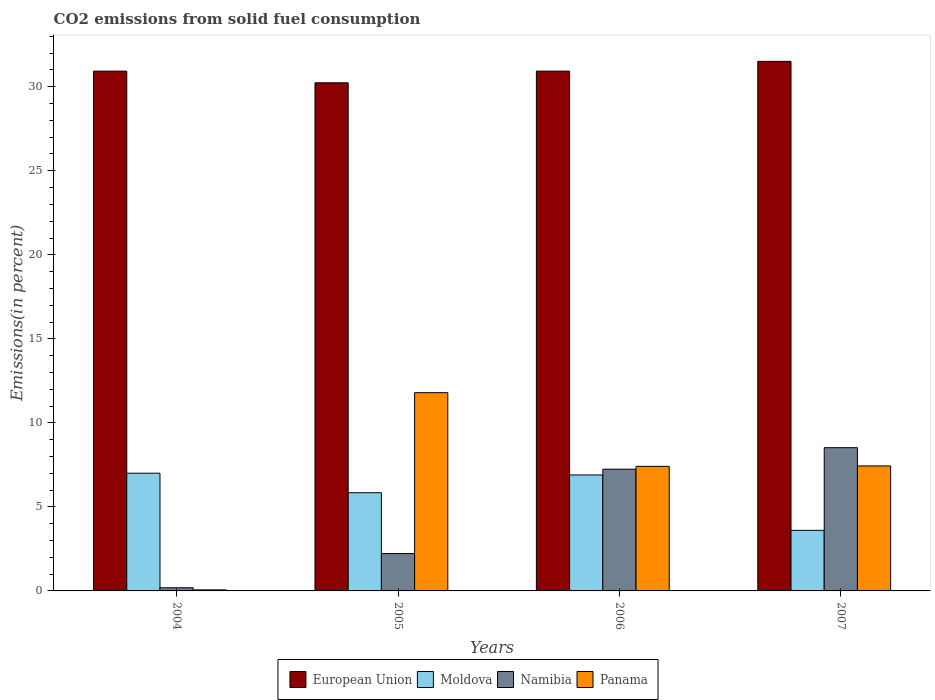How many different coloured bars are there?
Your answer should be compact. 4. How many bars are there on the 3rd tick from the left?
Give a very brief answer. 4. How many bars are there on the 2nd tick from the right?
Provide a succinct answer. 4. What is the label of the 1st group of bars from the left?
Your answer should be compact. 2004. What is the total CO2 emitted in Moldova in 2005?
Make the answer very short. 5.84. Across all years, what is the maximum total CO2 emitted in Panama?
Provide a short and direct response. 11.8. Across all years, what is the minimum total CO2 emitted in Namibia?
Your answer should be very brief. 0.19. In which year was the total CO2 emitted in Namibia maximum?
Your response must be concise. 2007. In which year was the total CO2 emitted in Namibia minimum?
Give a very brief answer. 2004. What is the total total CO2 emitted in European Union in the graph?
Ensure brevity in your answer.  123.61. What is the difference between the total CO2 emitted in Panama in 2005 and that in 2006?
Your answer should be compact. 4.38. What is the difference between the total CO2 emitted in Namibia in 2007 and the total CO2 emitted in European Union in 2004?
Ensure brevity in your answer.  -22.41. What is the average total CO2 emitted in Moldova per year?
Offer a very short reply. 5.84. In the year 2004, what is the difference between the total CO2 emitted in Panama and total CO2 emitted in Moldova?
Keep it short and to the point. -6.94. What is the ratio of the total CO2 emitted in Moldova in 2005 to that in 2007?
Provide a succinct answer. 1.62. Is the total CO2 emitted in Panama in 2005 less than that in 2006?
Your answer should be very brief. No. Is the difference between the total CO2 emitted in Panama in 2004 and 2005 greater than the difference between the total CO2 emitted in Moldova in 2004 and 2005?
Ensure brevity in your answer.  No. What is the difference between the highest and the second highest total CO2 emitted in Panama?
Make the answer very short. 4.36. What is the difference between the highest and the lowest total CO2 emitted in European Union?
Provide a succinct answer. 1.28. What does the 3rd bar from the left in 2007 represents?
Make the answer very short. Namibia. What does the 1st bar from the right in 2005 represents?
Provide a short and direct response. Panama. Is it the case that in every year, the sum of the total CO2 emitted in Namibia and total CO2 emitted in Moldova is greater than the total CO2 emitted in European Union?
Provide a succinct answer. No. Are all the bars in the graph horizontal?
Keep it short and to the point. No. Does the graph contain grids?
Your answer should be very brief. No. Where does the legend appear in the graph?
Provide a short and direct response. Bottom center. What is the title of the graph?
Give a very brief answer. CO2 emissions from solid fuel consumption. What is the label or title of the Y-axis?
Offer a very short reply. Emissions(in percent). What is the Emissions(in percent) of European Union in 2004?
Offer a very short reply. 30.93. What is the Emissions(in percent) in Moldova in 2004?
Provide a short and direct response. 7. What is the Emissions(in percent) of Namibia in 2004?
Offer a very short reply. 0.19. What is the Emissions(in percent) of Panama in 2004?
Ensure brevity in your answer.  0.06. What is the Emissions(in percent) of European Union in 2005?
Keep it short and to the point. 30.24. What is the Emissions(in percent) in Moldova in 2005?
Your answer should be compact. 5.84. What is the Emissions(in percent) in Namibia in 2005?
Ensure brevity in your answer.  2.22. What is the Emissions(in percent) of Panama in 2005?
Ensure brevity in your answer.  11.8. What is the Emissions(in percent) of European Union in 2006?
Give a very brief answer. 30.93. What is the Emissions(in percent) of Moldova in 2006?
Your answer should be compact. 6.9. What is the Emissions(in percent) of Namibia in 2006?
Give a very brief answer. 7.24. What is the Emissions(in percent) of Panama in 2006?
Ensure brevity in your answer.  7.41. What is the Emissions(in percent) in European Union in 2007?
Make the answer very short. 31.51. What is the Emissions(in percent) in Moldova in 2007?
Keep it short and to the point. 3.61. What is the Emissions(in percent) of Namibia in 2007?
Offer a very short reply. 8.52. What is the Emissions(in percent) in Panama in 2007?
Provide a succinct answer. 7.44. Across all years, what is the maximum Emissions(in percent) in European Union?
Your response must be concise. 31.51. Across all years, what is the maximum Emissions(in percent) of Moldova?
Give a very brief answer. 7. Across all years, what is the maximum Emissions(in percent) in Namibia?
Provide a succinct answer. 8.52. Across all years, what is the maximum Emissions(in percent) in Panama?
Provide a short and direct response. 11.8. Across all years, what is the minimum Emissions(in percent) of European Union?
Keep it short and to the point. 30.24. Across all years, what is the minimum Emissions(in percent) in Moldova?
Ensure brevity in your answer.  3.61. Across all years, what is the minimum Emissions(in percent) in Namibia?
Offer a very short reply. 0.19. Across all years, what is the minimum Emissions(in percent) of Panama?
Your answer should be very brief. 0.06. What is the total Emissions(in percent) of European Union in the graph?
Provide a succinct answer. 123.61. What is the total Emissions(in percent) in Moldova in the graph?
Keep it short and to the point. 23.35. What is the total Emissions(in percent) of Namibia in the graph?
Make the answer very short. 18.18. What is the total Emissions(in percent) of Panama in the graph?
Provide a succinct answer. 26.71. What is the difference between the Emissions(in percent) in European Union in 2004 and that in 2005?
Ensure brevity in your answer.  0.69. What is the difference between the Emissions(in percent) in Moldova in 2004 and that in 2005?
Offer a terse response. 1.16. What is the difference between the Emissions(in percent) in Namibia in 2004 and that in 2005?
Your answer should be compact. -2.04. What is the difference between the Emissions(in percent) of Panama in 2004 and that in 2005?
Offer a very short reply. -11.73. What is the difference between the Emissions(in percent) of European Union in 2004 and that in 2006?
Your answer should be compact. 0. What is the difference between the Emissions(in percent) of Moldova in 2004 and that in 2006?
Your answer should be very brief. 0.1. What is the difference between the Emissions(in percent) of Namibia in 2004 and that in 2006?
Give a very brief answer. -7.06. What is the difference between the Emissions(in percent) of Panama in 2004 and that in 2006?
Offer a very short reply. -7.35. What is the difference between the Emissions(in percent) of European Union in 2004 and that in 2007?
Your answer should be compact. -0.58. What is the difference between the Emissions(in percent) of Moldova in 2004 and that in 2007?
Your answer should be compact. 3.4. What is the difference between the Emissions(in percent) in Namibia in 2004 and that in 2007?
Make the answer very short. -8.34. What is the difference between the Emissions(in percent) in Panama in 2004 and that in 2007?
Make the answer very short. -7.37. What is the difference between the Emissions(in percent) of European Union in 2005 and that in 2006?
Your response must be concise. -0.69. What is the difference between the Emissions(in percent) in Moldova in 2005 and that in 2006?
Your response must be concise. -1.06. What is the difference between the Emissions(in percent) of Namibia in 2005 and that in 2006?
Provide a succinct answer. -5.02. What is the difference between the Emissions(in percent) of Panama in 2005 and that in 2006?
Your answer should be compact. 4.38. What is the difference between the Emissions(in percent) in European Union in 2005 and that in 2007?
Make the answer very short. -1.28. What is the difference between the Emissions(in percent) in Moldova in 2005 and that in 2007?
Provide a short and direct response. 2.24. What is the difference between the Emissions(in percent) in Namibia in 2005 and that in 2007?
Offer a terse response. -6.3. What is the difference between the Emissions(in percent) of Panama in 2005 and that in 2007?
Offer a very short reply. 4.36. What is the difference between the Emissions(in percent) of European Union in 2006 and that in 2007?
Offer a terse response. -0.58. What is the difference between the Emissions(in percent) in Moldova in 2006 and that in 2007?
Give a very brief answer. 3.3. What is the difference between the Emissions(in percent) in Namibia in 2006 and that in 2007?
Make the answer very short. -1.28. What is the difference between the Emissions(in percent) of Panama in 2006 and that in 2007?
Make the answer very short. -0.02. What is the difference between the Emissions(in percent) in European Union in 2004 and the Emissions(in percent) in Moldova in 2005?
Make the answer very short. 25.09. What is the difference between the Emissions(in percent) in European Union in 2004 and the Emissions(in percent) in Namibia in 2005?
Offer a terse response. 28.71. What is the difference between the Emissions(in percent) of European Union in 2004 and the Emissions(in percent) of Panama in 2005?
Your answer should be very brief. 19.13. What is the difference between the Emissions(in percent) of Moldova in 2004 and the Emissions(in percent) of Namibia in 2005?
Offer a terse response. 4.78. What is the difference between the Emissions(in percent) of Moldova in 2004 and the Emissions(in percent) of Panama in 2005?
Provide a short and direct response. -4.79. What is the difference between the Emissions(in percent) of Namibia in 2004 and the Emissions(in percent) of Panama in 2005?
Your answer should be compact. -11.61. What is the difference between the Emissions(in percent) of European Union in 2004 and the Emissions(in percent) of Moldova in 2006?
Ensure brevity in your answer.  24.03. What is the difference between the Emissions(in percent) in European Union in 2004 and the Emissions(in percent) in Namibia in 2006?
Make the answer very short. 23.69. What is the difference between the Emissions(in percent) in European Union in 2004 and the Emissions(in percent) in Panama in 2006?
Keep it short and to the point. 23.52. What is the difference between the Emissions(in percent) of Moldova in 2004 and the Emissions(in percent) of Namibia in 2006?
Offer a very short reply. -0.24. What is the difference between the Emissions(in percent) in Moldova in 2004 and the Emissions(in percent) in Panama in 2006?
Ensure brevity in your answer.  -0.41. What is the difference between the Emissions(in percent) of Namibia in 2004 and the Emissions(in percent) of Panama in 2006?
Your answer should be very brief. -7.23. What is the difference between the Emissions(in percent) of European Union in 2004 and the Emissions(in percent) of Moldova in 2007?
Provide a succinct answer. 27.33. What is the difference between the Emissions(in percent) in European Union in 2004 and the Emissions(in percent) in Namibia in 2007?
Keep it short and to the point. 22.41. What is the difference between the Emissions(in percent) in European Union in 2004 and the Emissions(in percent) in Panama in 2007?
Your answer should be compact. 23.49. What is the difference between the Emissions(in percent) of Moldova in 2004 and the Emissions(in percent) of Namibia in 2007?
Give a very brief answer. -1.52. What is the difference between the Emissions(in percent) of Moldova in 2004 and the Emissions(in percent) of Panama in 2007?
Keep it short and to the point. -0.43. What is the difference between the Emissions(in percent) of Namibia in 2004 and the Emissions(in percent) of Panama in 2007?
Your answer should be compact. -7.25. What is the difference between the Emissions(in percent) of European Union in 2005 and the Emissions(in percent) of Moldova in 2006?
Ensure brevity in your answer.  23.34. What is the difference between the Emissions(in percent) in European Union in 2005 and the Emissions(in percent) in Namibia in 2006?
Make the answer very short. 22.99. What is the difference between the Emissions(in percent) of European Union in 2005 and the Emissions(in percent) of Panama in 2006?
Offer a terse response. 22.82. What is the difference between the Emissions(in percent) of Moldova in 2005 and the Emissions(in percent) of Namibia in 2006?
Provide a short and direct response. -1.4. What is the difference between the Emissions(in percent) in Moldova in 2005 and the Emissions(in percent) in Panama in 2006?
Make the answer very short. -1.57. What is the difference between the Emissions(in percent) of Namibia in 2005 and the Emissions(in percent) of Panama in 2006?
Your answer should be compact. -5.19. What is the difference between the Emissions(in percent) in European Union in 2005 and the Emissions(in percent) in Moldova in 2007?
Your answer should be compact. 26.63. What is the difference between the Emissions(in percent) of European Union in 2005 and the Emissions(in percent) of Namibia in 2007?
Your response must be concise. 21.71. What is the difference between the Emissions(in percent) in European Union in 2005 and the Emissions(in percent) in Panama in 2007?
Provide a succinct answer. 22.8. What is the difference between the Emissions(in percent) in Moldova in 2005 and the Emissions(in percent) in Namibia in 2007?
Give a very brief answer. -2.68. What is the difference between the Emissions(in percent) of Moldova in 2005 and the Emissions(in percent) of Panama in 2007?
Keep it short and to the point. -1.59. What is the difference between the Emissions(in percent) of Namibia in 2005 and the Emissions(in percent) of Panama in 2007?
Offer a very short reply. -5.22. What is the difference between the Emissions(in percent) of European Union in 2006 and the Emissions(in percent) of Moldova in 2007?
Make the answer very short. 27.33. What is the difference between the Emissions(in percent) of European Union in 2006 and the Emissions(in percent) of Namibia in 2007?
Your answer should be very brief. 22.41. What is the difference between the Emissions(in percent) of European Union in 2006 and the Emissions(in percent) of Panama in 2007?
Your response must be concise. 23.49. What is the difference between the Emissions(in percent) of Moldova in 2006 and the Emissions(in percent) of Namibia in 2007?
Your answer should be very brief. -1.62. What is the difference between the Emissions(in percent) in Moldova in 2006 and the Emissions(in percent) in Panama in 2007?
Offer a terse response. -0.54. What is the difference between the Emissions(in percent) in Namibia in 2006 and the Emissions(in percent) in Panama in 2007?
Offer a terse response. -0.19. What is the average Emissions(in percent) of European Union per year?
Your response must be concise. 30.9. What is the average Emissions(in percent) in Moldova per year?
Ensure brevity in your answer.  5.84. What is the average Emissions(in percent) of Namibia per year?
Provide a succinct answer. 4.54. What is the average Emissions(in percent) of Panama per year?
Make the answer very short. 6.68. In the year 2004, what is the difference between the Emissions(in percent) of European Union and Emissions(in percent) of Moldova?
Your response must be concise. 23.93. In the year 2004, what is the difference between the Emissions(in percent) of European Union and Emissions(in percent) of Namibia?
Provide a short and direct response. 30.74. In the year 2004, what is the difference between the Emissions(in percent) in European Union and Emissions(in percent) in Panama?
Keep it short and to the point. 30.87. In the year 2004, what is the difference between the Emissions(in percent) of Moldova and Emissions(in percent) of Namibia?
Provide a succinct answer. 6.82. In the year 2004, what is the difference between the Emissions(in percent) in Moldova and Emissions(in percent) in Panama?
Make the answer very short. 6.94. In the year 2004, what is the difference between the Emissions(in percent) in Namibia and Emissions(in percent) in Panama?
Offer a terse response. 0.12. In the year 2005, what is the difference between the Emissions(in percent) in European Union and Emissions(in percent) in Moldova?
Give a very brief answer. 24.39. In the year 2005, what is the difference between the Emissions(in percent) of European Union and Emissions(in percent) of Namibia?
Your answer should be compact. 28.01. In the year 2005, what is the difference between the Emissions(in percent) in European Union and Emissions(in percent) in Panama?
Keep it short and to the point. 18.44. In the year 2005, what is the difference between the Emissions(in percent) of Moldova and Emissions(in percent) of Namibia?
Your response must be concise. 3.62. In the year 2005, what is the difference between the Emissions(in percent) in Moldova and Emissions(in percent) in Panama?
Your response must be concise. -5.95. In the year 2005, what is the difference between the Emissions(in percent) of Namibia and Emissions(in percent) of Panama?
Your answer should be very brief. -9.57. In the year 2006, what is the difference between the Emissions(in percent) in European Union and Emissions(in percent) in Moldova?
Your answer should be very brief. 24.03. In the year 2006, what is the difference between the Emissions(in percent) in European Union and Emissions(in percent) in Namibia?
Make the answer very short. 23.69. In the year 2006, what is the difference between the Emissions(in percent) in European Union and Emissions(in percent) in Panama?
Your response must be concise. 23.52. In the year 2006, what is the difference between the Emissions(in percent) of Moldova and Emissions(in percent) of Namibia?
Your response must be concise. -0.34. In the year 2006, what is the difference between the Emissions(in percent) in Moldova and Emissions(in percent) in Panama?
Your answer should be very brief. -0.51. In the year 2006, what is the difference between the Emissions(in percent) in Namibia and Emissions(in percent) in Panama?
Offer a very short reply. -0.17. In the year 2007, what is the difference between the Emissions(in percent) in European Union and Emissions(in percent) in Moldova?
Offer a very short reply. 27.91. In the year 2007, what is the difference between the Emissions(in percent) of European Union and Emissions(in percent) of Namibia?
Make the answer very short. 22.99. In the year 2007, what is the difference between the Emissions(in percent) of European Union and Emissions(in percent) of Panama?
Your answer should be very brief. 24.07. In the year 2007, what is the difference between the Emissions(in percent) in Moldova and Emissions(in percent) in Namibia?
Provide a short and direct response. -4.92. In the year 2007, what is the difference between the Emissions(in percent) in Moldova and Emissions(in percent) in Panama?
Provide a short and direct response. -3.83. In the year 2007, what is the difference between the Emissions(in percent) in Namibia and Emissions(in percent) in Panama?
Your answer should be compact. 1.09. What is the ratio of the Emissions(in percent) in Moldova in 2004 to that in 2005?
Provide a short and direct response. 1.2. What is the ratio of the Emissions(in percent) of Namibia in 2004 to that in 2005?
Your answer should be compact. 0.08. What is the ratio of the Emissions(in percent) in Panama in 2004 to that in 2005?
Provide a succinct answer. 0.01. What is the ratio of the Emissions(in percent) in Moldova in 2004 to that in 2006?
Give a very brief answer. 1.01. What is the ratio of the Emissions(in percent) in Namibia in 2004 to that in 2006?
Keep it short and to the point. 0.03. What is the ratio of the Emissions(in percent) of Panama in 2004 to that in 2006?
Offer a terse response. 0.01. What is the ratio of the Emissions(in percent) in European Union in 2004 to that in 2007?
Ensure brevity in your answer.  0.98. What is the ratio of the Emissions(in percent) in Moldova in 2004 to that in 2007?
Offer a terse response. 1.94. What is the ratio of the Emissions(in percent) of Namibia in 2004 to that in 2007?
Give a very brief answer. 0.02. What is the ratio of the Emissions(in percent) in Panama in 2004 to that in 2007?
Your answer should be compact. 0.01. What is the ratio of the Emissions(in percent) in European Union in 2005 to that in 2006?
Offer a very short reply. 0.98. What is the ratio of the Emissions(in percent) in Moldova in 2005 to that in 2006?
Your answer should be very brief. 0.85. What is the ratio of the Emissions(in percent) in Namibia in 2005 to that in 2006?
Your answer should be compact. 0.31. What is the ratio of the Emissions(in percent) of Panama in 2005 to that in 2006?
Keep it short and to the point. 1.59. What is the ratio of the Emissions(in percent) in European Union in 2005 to that in 2007?
Offer a terse response. 0.96. What is the ratio of the Emissions(in percent) of Moldova in 2005 to that in 2007?
Offer a very short reply. 1.62. What is the ratio of the Emissions(in percent) in Namibia in 2005 to that in 2007?
Keep it short and to the point. 0.26. What is the ratio of the Emissions(in percent) in Panama in 2005 to that in 2007?
Provide a succinct answer. 1.59. What is the ratio of the Emissions(in percent) of European Union in 2006 to that in 2007?
Keep it short and to the point. 0.98. What is the ratio of the Emissions(in percent) of Moldova in 2006 to that in 2007?
Offer a very short reply. 1.91. What is the ratio of the Emissions(in percent) in Namibia in 2006 to that in 2007?
Provide a short and direct response. 0.85. What is the difference between the highest and the second highest Emissions(in percent) of European Union?
Provide a short and direct response. 0.58. What is the difference between the highest and the second highest Emissions(in percent) in Moldova?
Provide a short and direct response. 0.1. What is the difference between the highest and the second highest Emissions(in percent) in Namibia?
Make the answer very short. 1.28. What is the difference between the highest and the second highest Emissions(in percent) of Panama?
Your response must be concise. 4.36. What is the difference between the highest and the lowest Emissions(in percent) in European Union?
Your response must be concise. 1.28. What is the difference between the highest and the lowest Emissions(in percent) of Moldova?
Ensure brevity in your answer.  3.4. What is the difference between the highest and the lowest Emissions(in percent) of Namibia?
Your answer should be very brief. 8.34. What is the difference between the highest and the lowest Emissions(in percent) of Panama?
Provide a short and direct response. 11.73. 